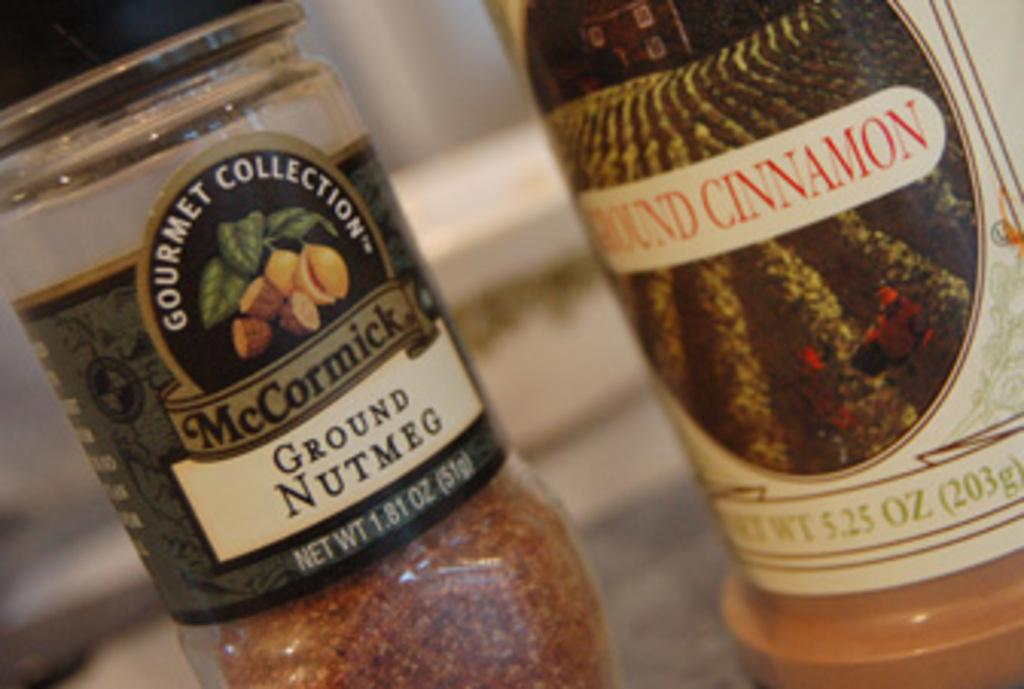<image>
Share a concise interpretation of the image provided. A ground nutmeg bottle sits next to a ground cinnamon bottle. 